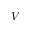Convert formula to latex. <formula><loc_0><loc_0><loc_500><loc_500>V</formula> 